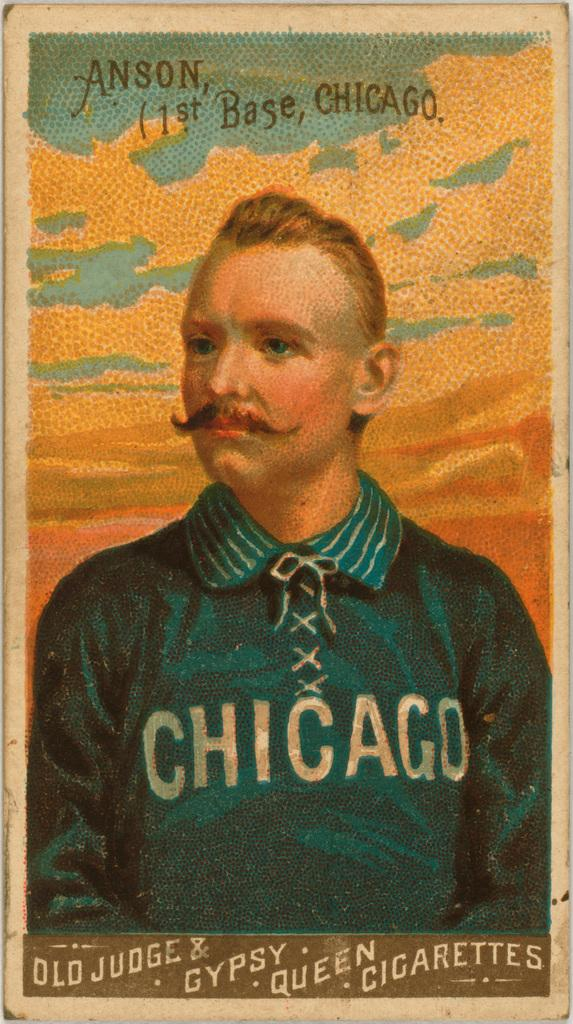<image>
Share a concise interpretation of the image provided. A cigarette case with a picture of a man in a Chicago shirt. 